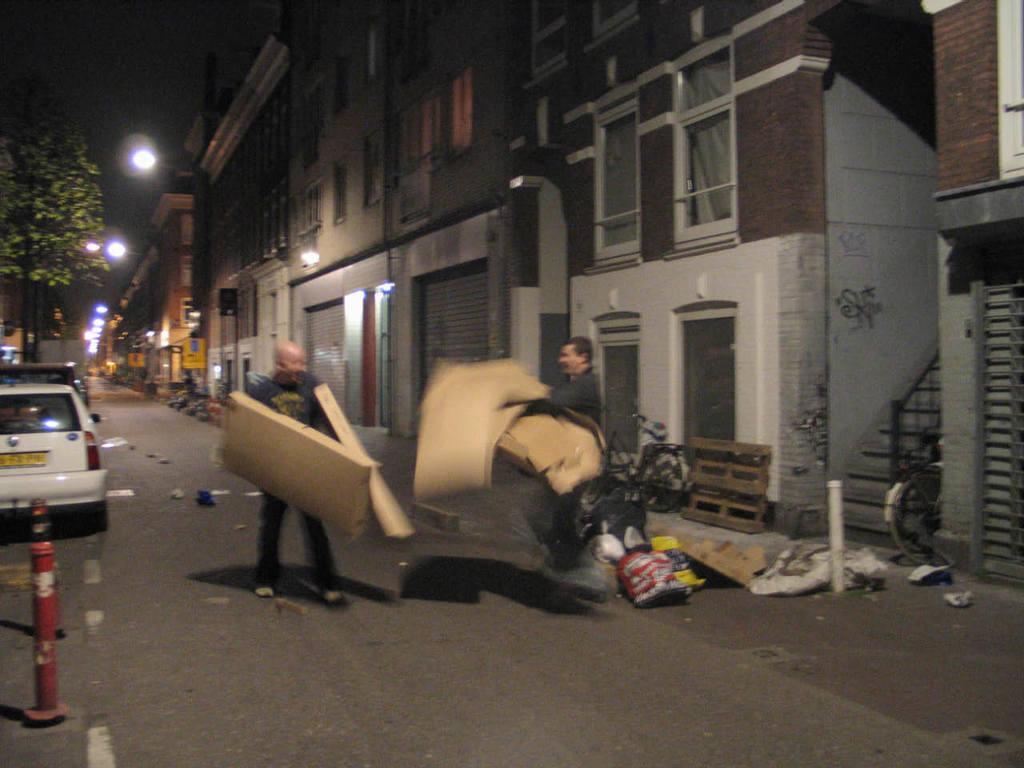Could you give a brief overview of what you see in this image? This image is clicked on the road. In the foreground there are two men standing. They are holding objects in their hands. To the left there are cars parked on the road. To the right there are buildings. In front of the building there are street light poles. There is a tree in the image. At the top there is the sky. 